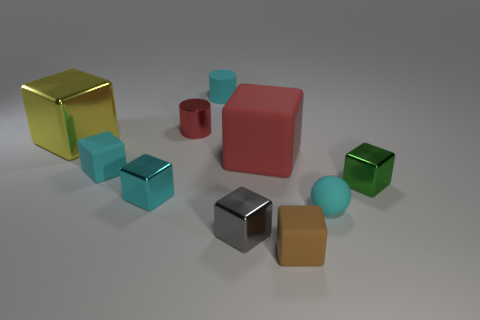There is a large object that is on the right side of the cyan shiny object; is its color the same as the tiny metallic cylinder?
Your response must be concise. Yes. How many cyan metallic things have the same shape as the tiny brown object?
Your answer should be very brief. 1. Are there an equal number of red shiny cylinders on the left side of the tiny red metallic thing and cyan metal things?
Your response must be concise. No. There is a shiny cylinder that is the same size as the gray metallic block; what color is it?
Provide a short and direct response. Red. Is there a small cyan metallic object that has the same shape as the gray metal object?
Keep it short and to the point. Yes. The tiny cyan cube that is in front of the small green metallic thing that is right of the small gray metal cube right of the cyan metallic block is made of what material?
Keep it short and to the point. Metal. What number of other objects are the same size as the yellow metallic object?
Offer a very short reply. 1. The ball is what color?
Your answer should be very brief. Cyan. What number of shiny things are large blocks or green cubes?
Keep it short and to the point. 2. There is a thing to the left of the tiny cyan cube that is behind the tiny metallic cube on the left side of the small gray shiny cube; what is its size?
Offer a very short reply. Large. 